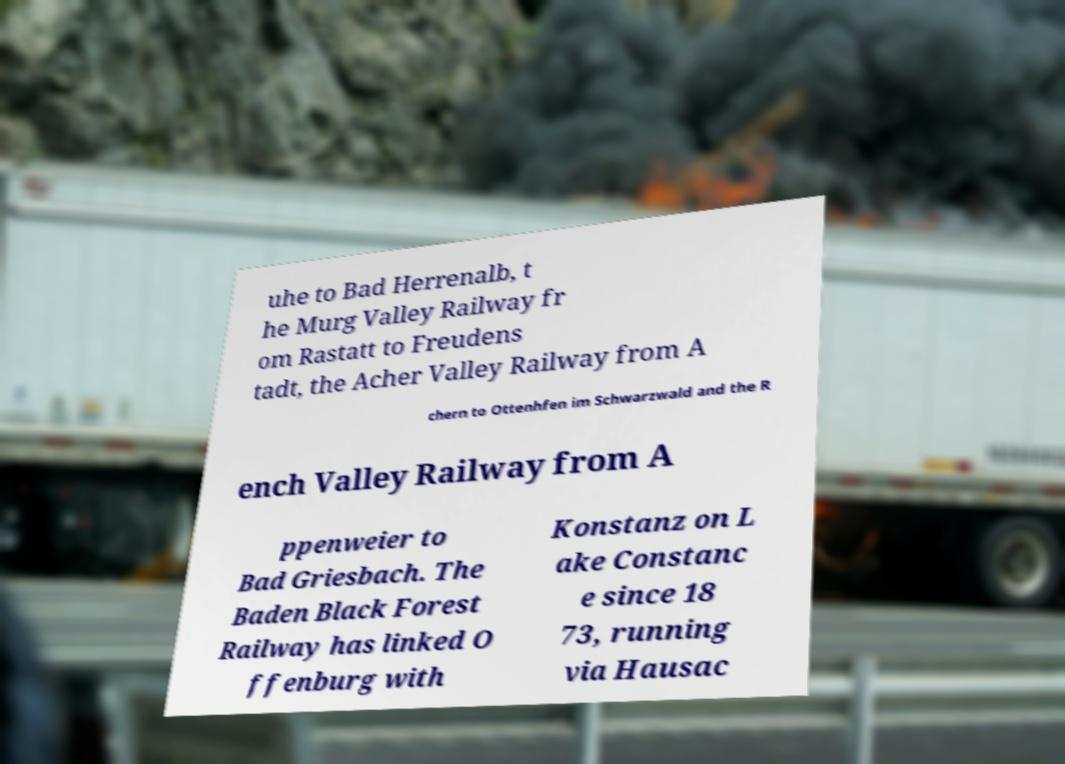Could you extract and type out the text from this image? uhe to Bad Herrenalb, t he Murg Valley Railway fr om Rastatt to Freudens tadt, the Acher Valley Railway from A chern to Ottenhfen im Schwarzwald and the R ench Valley Railway from A ppenweier to Bad Griesbach. The Baden Black Forest Railway has linked O ffenburg with Konstanz on L ake Constanc e since 18 73, running via Hausac 